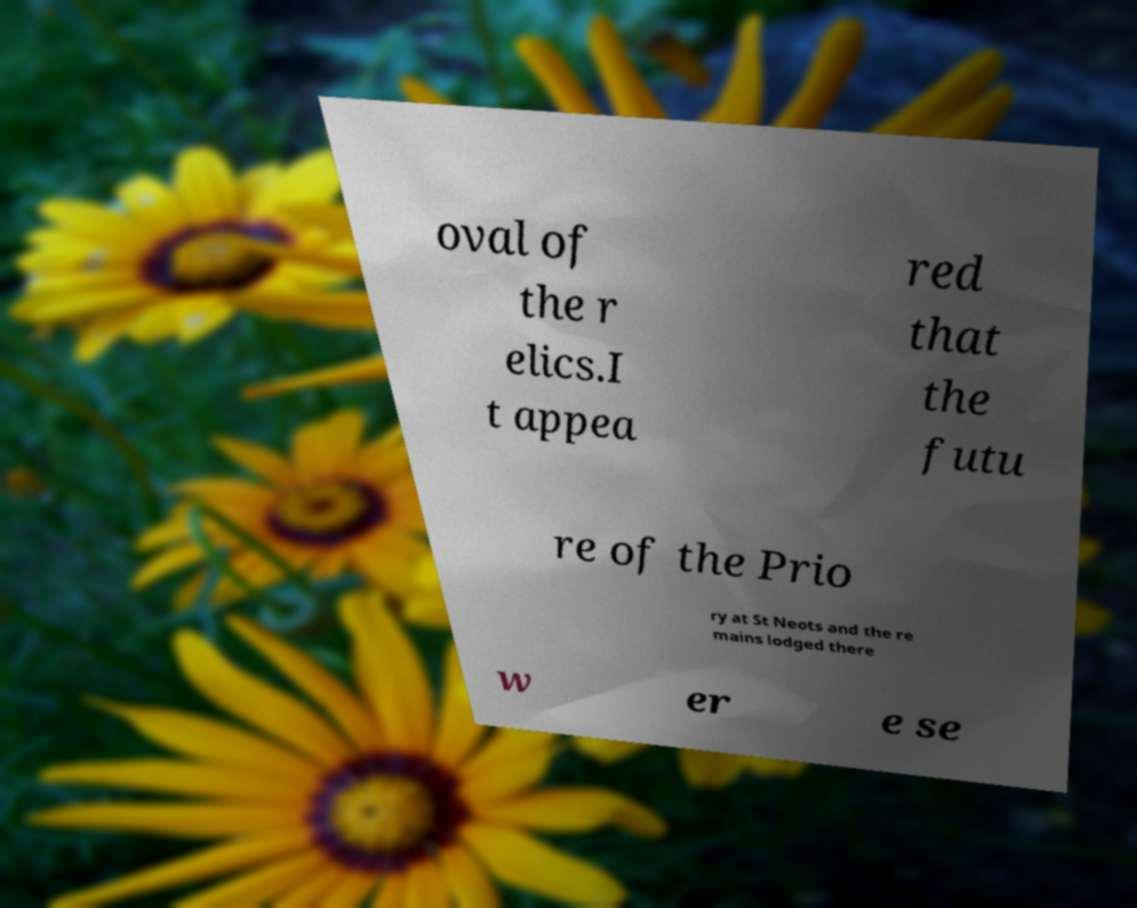Can you read and provide the text displayed in the image?This photo seems to have some interesting text. Can you extract and type it out for me? oval of the r elics.I t appea red that the futu re of the Prio ry at St Neots and the re mains lodged there w er e se 